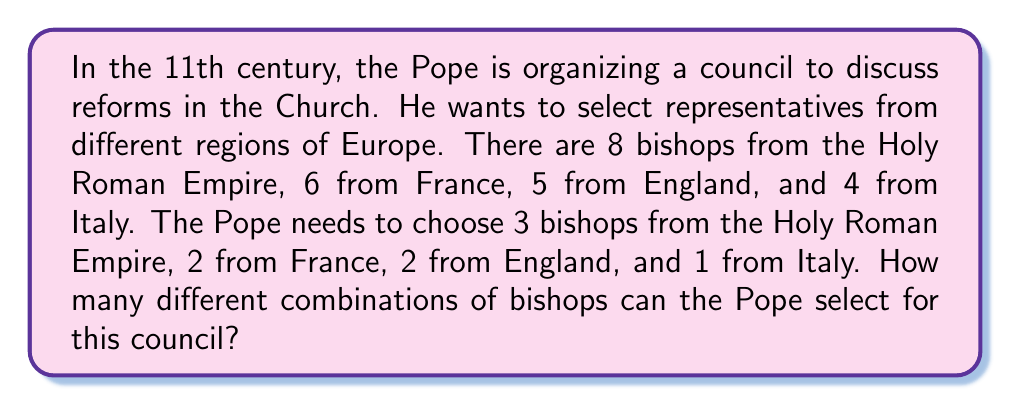Solve this math problem. To solve this problem, we need to use the combination formula for each region and then apply the multiplication principle.

1. For the Holy Roman Empire:
   We need to choose 3 bishops out of 8. This can be calculated using the combination formula:
   $$\binom{8}{3} = \frac{8!}{3!(8-3)!} = \frac{8!}{3!5!} = 56$$

2. For France:
   We need to choose 2 bishops out of 6:
   $$\binom{6}{2} = \frac{6!}{2!(6-2)!} = \frac{6!}{2!4!} = 15$$

3. For England:
   We need to choose 2 bishops out of 5:
   $$\binom{5}{2} = \frac{5!}{2!(5-2)!} = \frac{5!}{2!3!} = 10$$

4. For Italy:
   We need to choose 1 bishop out of 4:
   $$\binom{4}{1} = \frac{4!}{1!(4-1)!} = \frac{4!}{1!3!} = 4$$

Now, according to the multiplication principle, to find the total number of possible combinations, we multiply these individual results:

$$ 56 \times 15 \times 10 \times 4 = 33,600 $$
Answer: The Pope can select 33,600 different combinations of bishops for the council. 